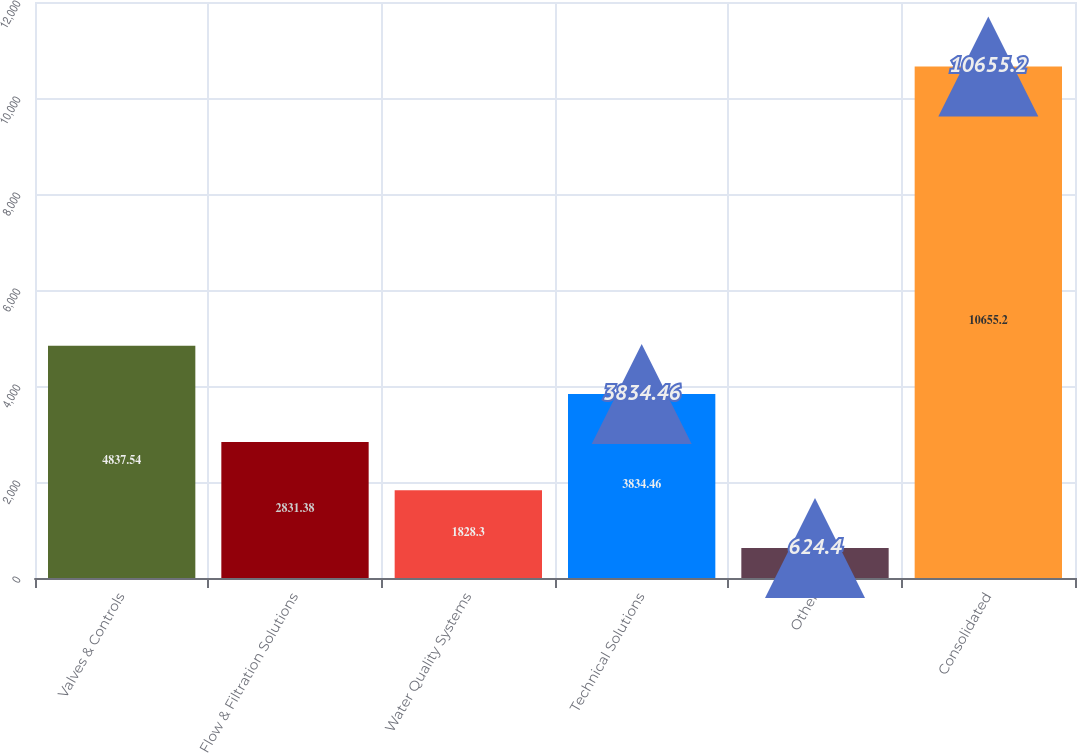<chart> <loc_0><loc_0><loc_500><loc_500><bar_chart><fcel>Valves & Controls<fcel>Flow & Filtration Solutions<fcel>Water Quality Systems<fcel>Technical Solutions<fcel>Other<fcel>Consolidated<nl><fcel>4837.54<fcel>2831.38<fcel>1828.3<fcel>3834.46<fcel>624.4<fcel>10655.2<nl></chart> 